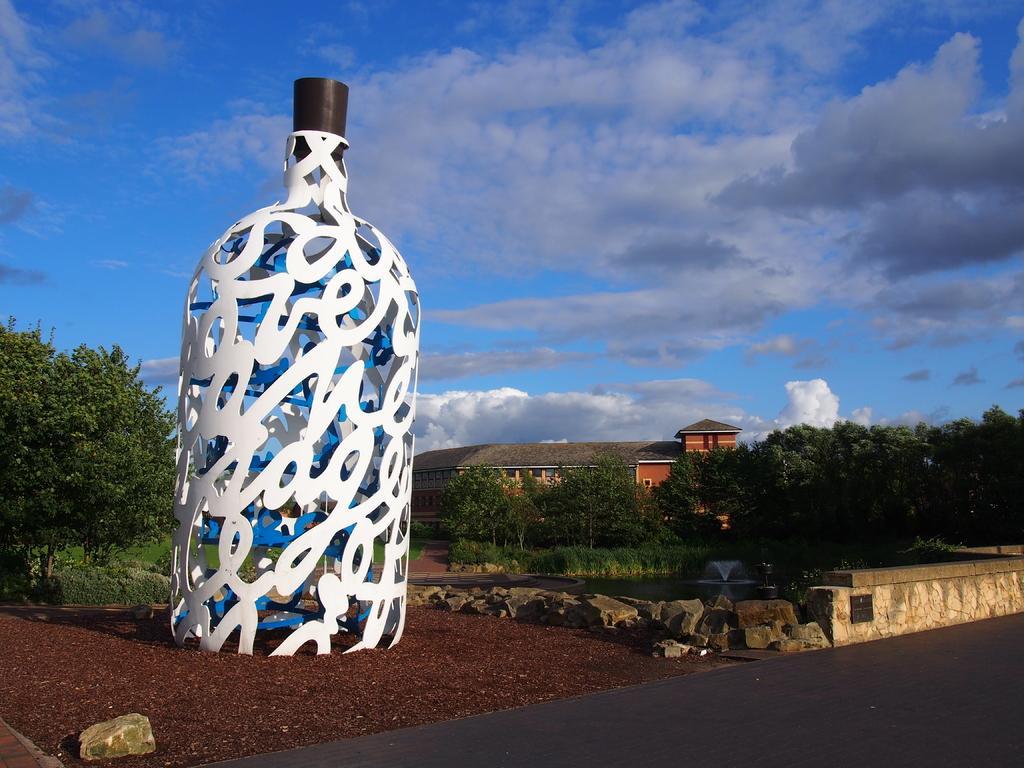Could you give a brief overview of what you see in this image? In this image we can see a large vase with a lid on it placed on the ground. We can also see the road, fence, some stones and a fountain. On the backside we can see a group of trees, plants, a house with roof and windows and the sky which looks cloudy. 